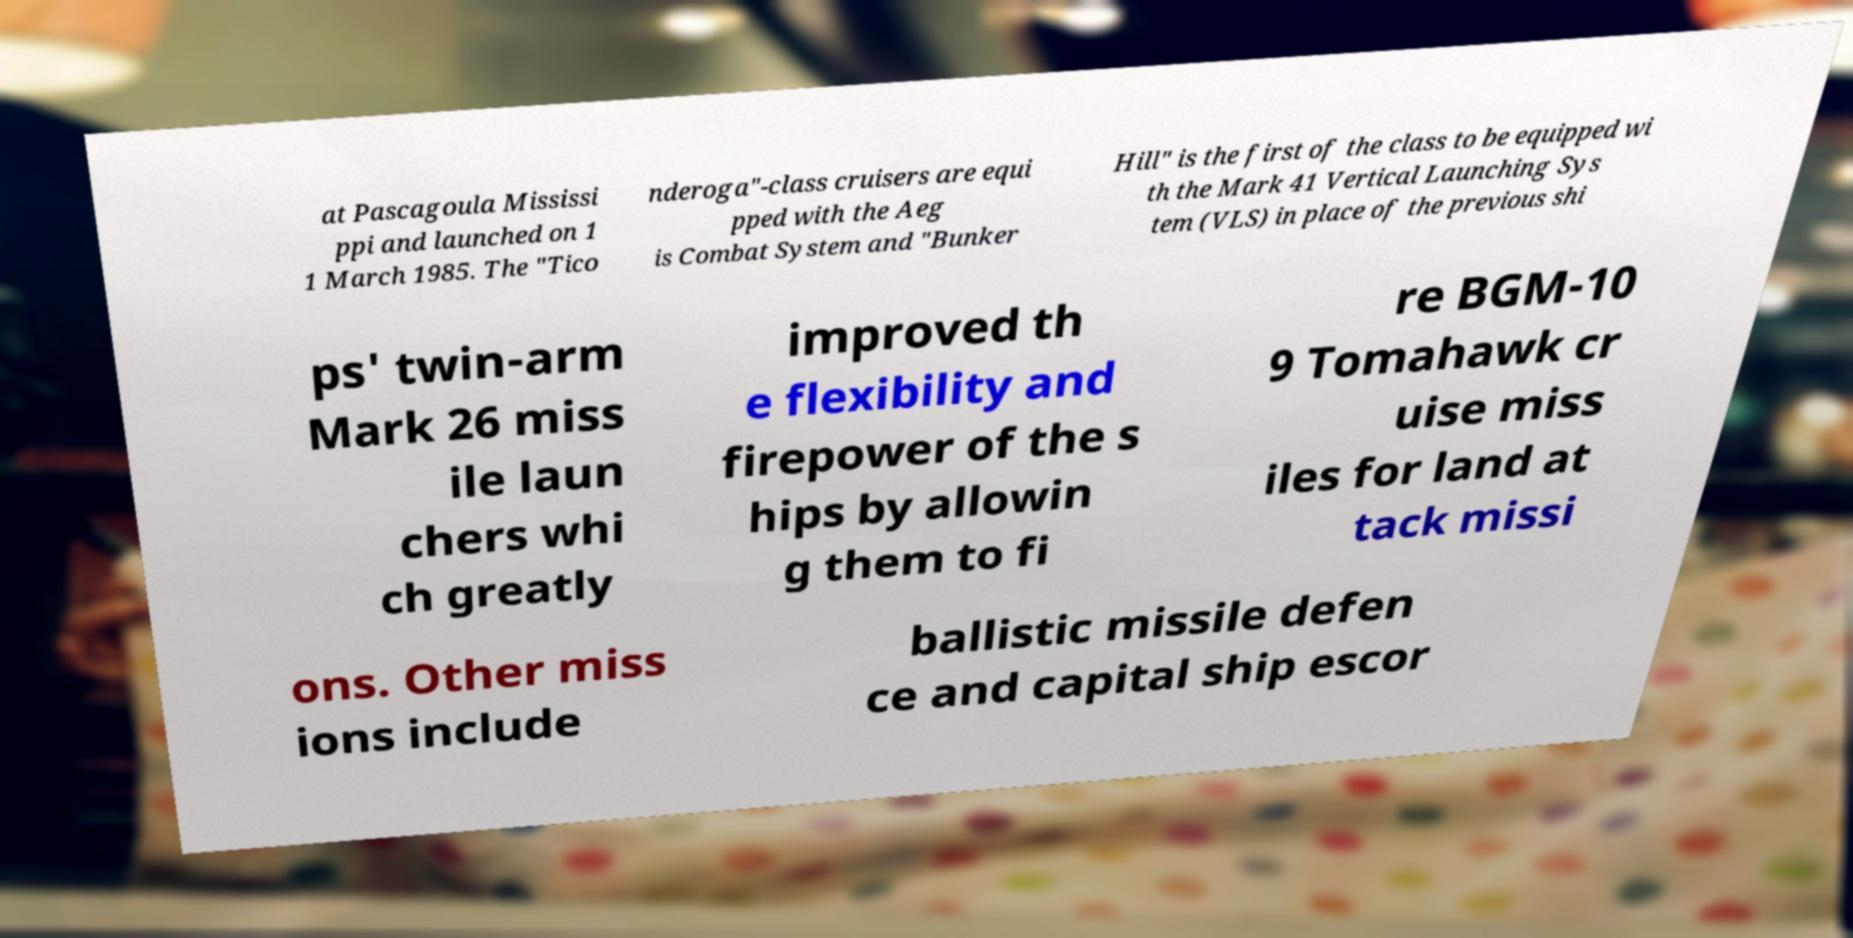Please read and relay the text visible in this image. What does it say? at Pascagoula Mississi ppi and launched on 1 1 March 1985. The "Tico nderoga"-class cruisers are equi pped with the Aeg is Combat System and "Bunker Hill" is the first of the class to be equipped wi th the Mark 41 Vertical Launching Sys tem (VLS) in place of the previous shi ps' twin-arm Mark 26 miss ile laun chers whi ch greatly improved th e flexibility and firepower of the s hips by allowin g them to fi re BGM-10 9 Tomahawk cr uise miss iles for land at tack missi ons. Other miss ions include ballistic missile defen ce and capital ship escor 